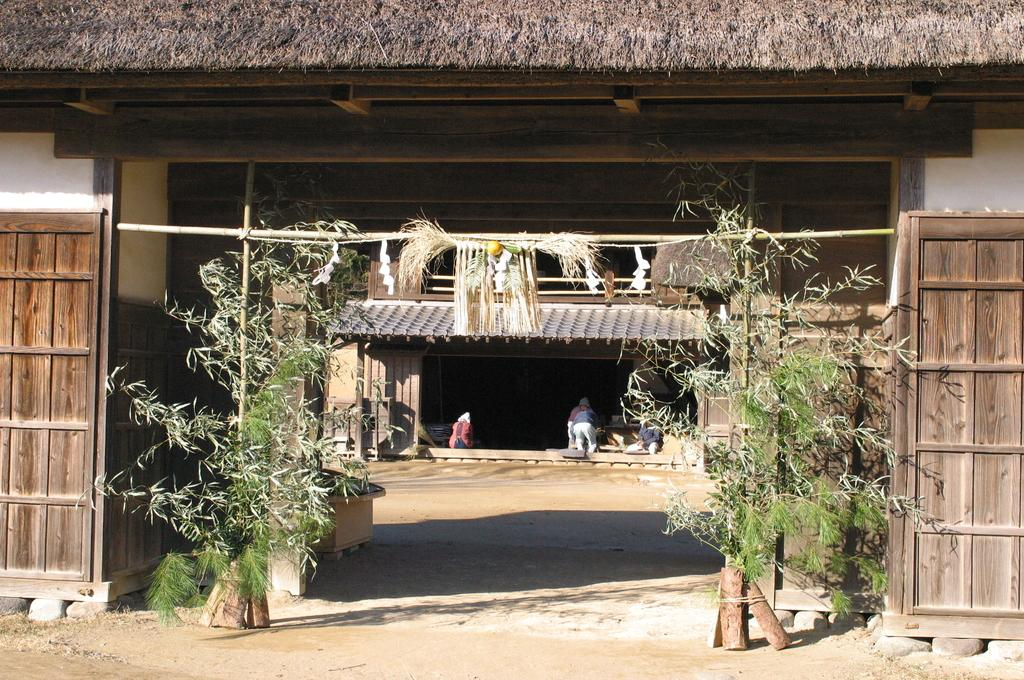What type of vegetation can be seen on both sides of the image? There are plants on both sides of the image. What can be seen in the background of the image? There is a building and people visible in the background of the image. What year is the alarm set to in the image? There is no alarm present in the image, so it is not possible to determine the year it is set to. 